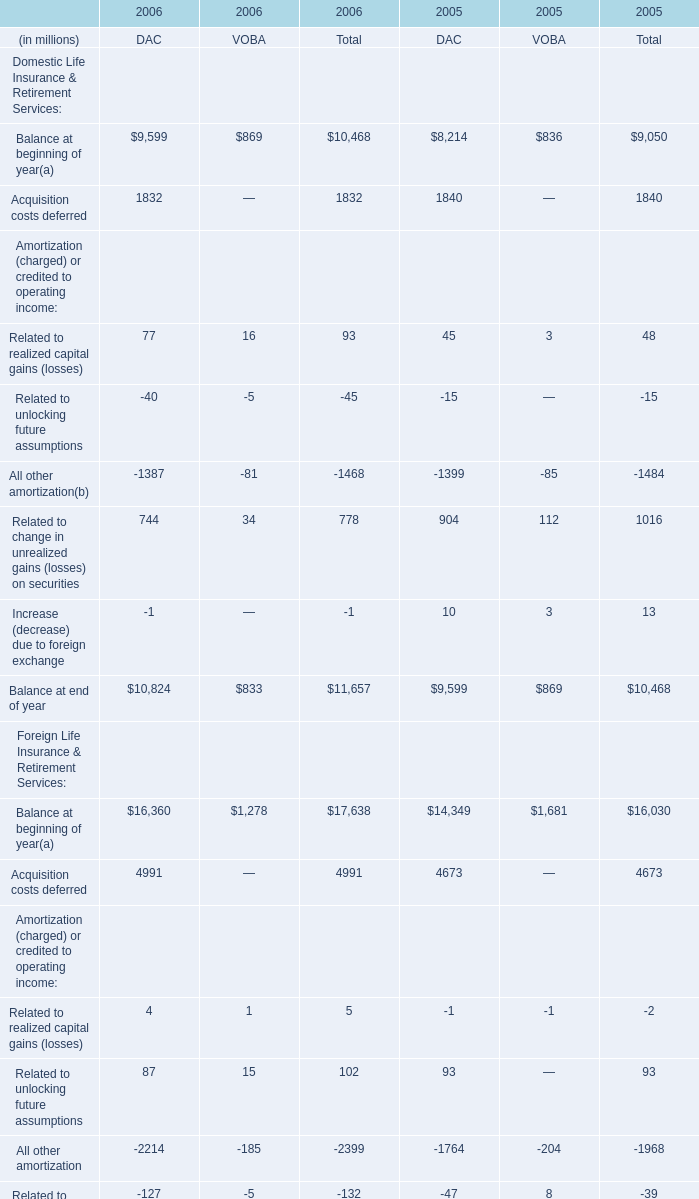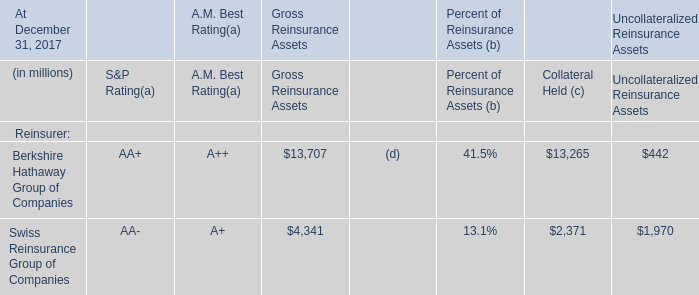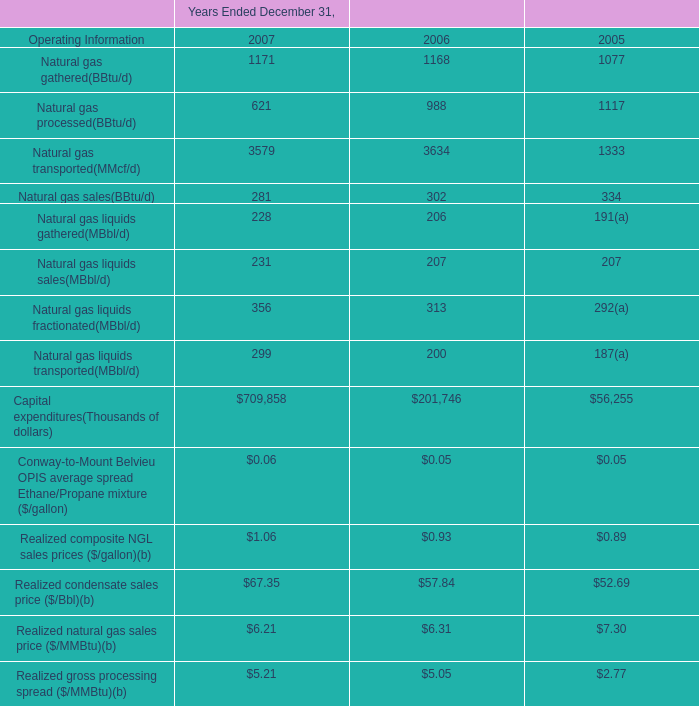what were the increased one time benefits from non-cash charges from 2006 to 2007? 
Computations: ((8.3 + 12.0) * 1000000)
Answer: 20300000.0. 